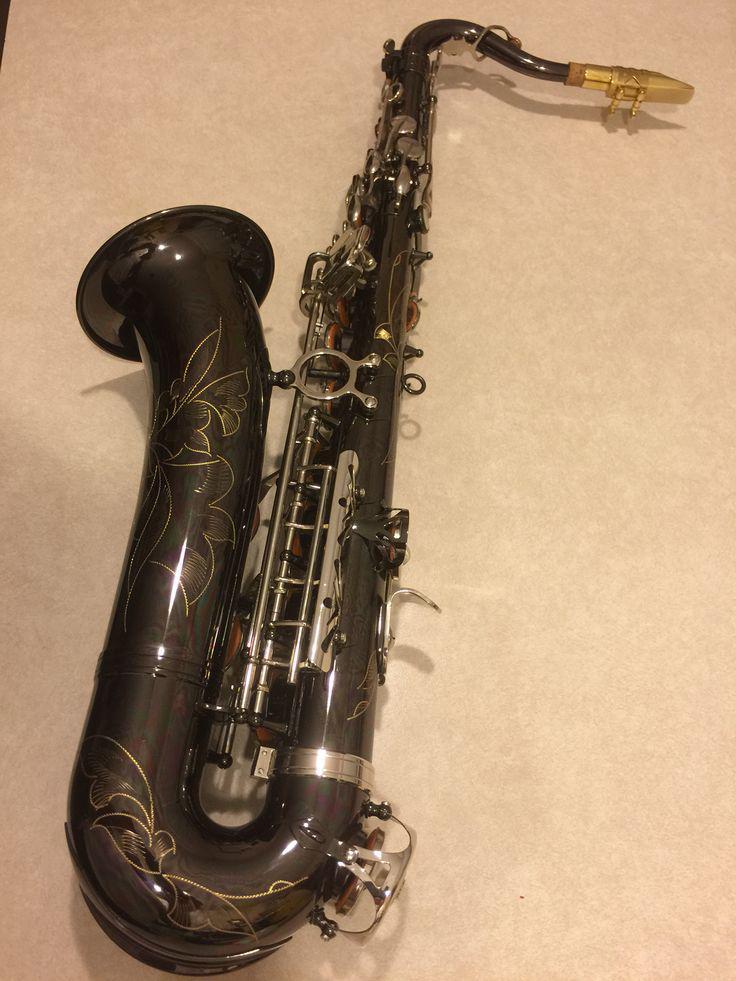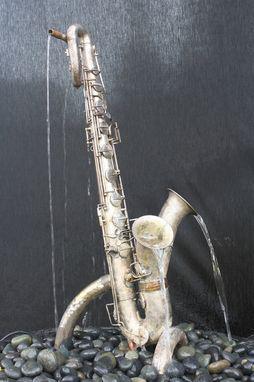The first image is the image on the left, the second image is the image on the right. Analyze the images presented: Is the assertion "At least one sax has water coming out of it." valid? Answer yes or no. Yes. The first image is the image on the left, the second image is the image on the right. For the images displayed, is the sentence "In one or more if the images a musical instrument has been converted to function as a water fountain." factually correct? Answer yes or no. Yes. 